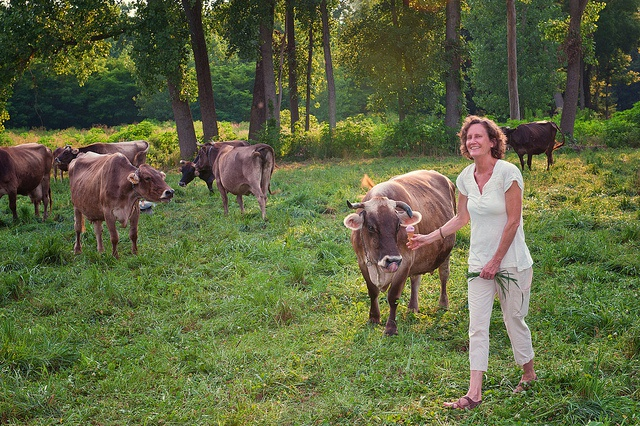Describe the objects in this image and their specific colors. I can see people in white, darkgray, lightgray, brown, and lightpink tones, cow in white, gray, brown, maroon, and black tones, cow in white, maroon, brown, gray, and black tones, cow in white, gray, and black tones, and cow in white, black, maroon, and brown tones in this image. 